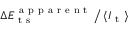Convert formula to latex. <formula><loc_0><loc_0><loc_500><loc_500>\Delta E _ { t s } ^ { a p p a r e n t } \, \Big / \, \langle I _ { t } \rangle</formula> 